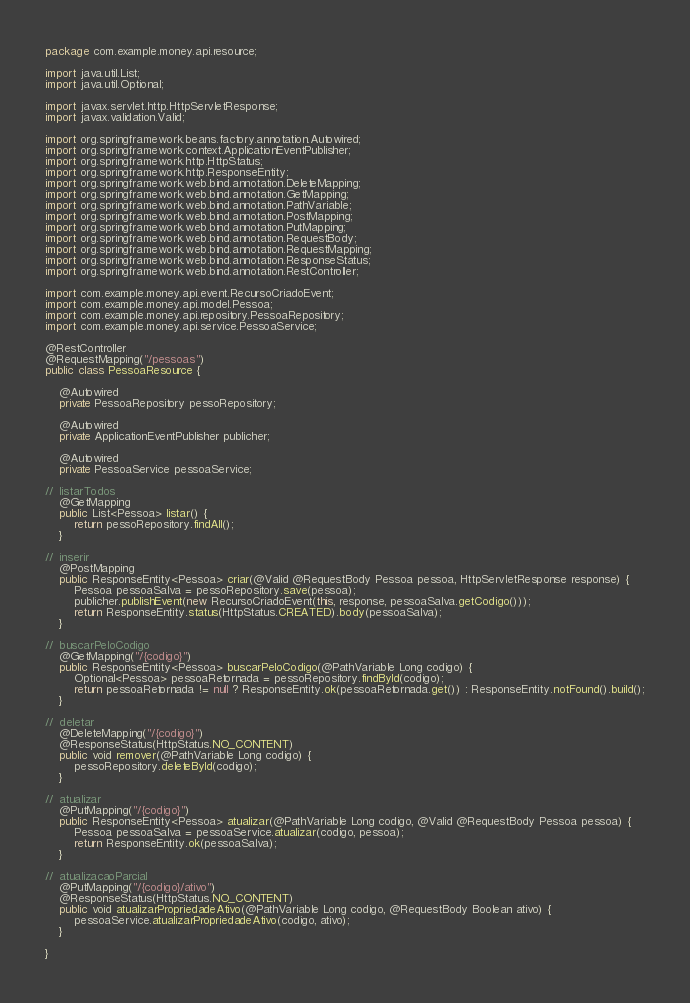<code> <loc_0><loc_0><loc_500><loc_500><_Java_>package com.example.money.api.resource;

import java.util.List;
import java.util.Optional;

import javax.servlet.http.HttpServletResponse;
import javax.validation.Valid;

import org.springframework.beans.factory.annotation.Autowired;
import org.springframework.context.ApplicationEventPublisher;
import org.springframework.http.HttpStatus;
import org.springframework.http.ResponseEntity;
import org.springframework.web.bind.annotation.DeleteMapping;
import org.springframework.web.bind.annotation.GetMapping;
import org.springframework.web.bind.annotation.PathVariable;
import org.springframework.web.bind.annotation.PostMapping;
import org.springframework.web.bind.annotation.PutMapping;
import org.springframework.web.bind.annotation.RequestBody;
import org.springframework.web.bind.annotation.RequestMapping;
import org.springframework.web.bind.annotation.ResponseStatus;
import org.springframework.web.bind.annotation.RestController;

import com.example.money.api.event.RecursoCriadoEvent;
import com.example.money.api.model.Pessoa;
import com.example.money.api.repository.PessoaRepository;
import com.example.money.api.service.PessoaService;

@RestController
@RequestMapping("/pessoas")
public class PessoaResource {

	@Autowired
	private PessoaRepository pessoRepository;

	@Autowired
	private ApplicationEventPublisher publicher;

	@Autowired
	private PessoaService pessoaService;

//	listarTodos
	@GetMapping
	public List<Pessoa> listar() {
		return pessoRepository.findAll();
	}

//	inserir
	@PostMapping
	public ResponseEntity<Pessoa> criar(@Valid @RequestBody Pessoa pessoa, HttpServletResponse response) {
		Pessoa pessoaSalva = pessoRepository.save(pessoa);
		publicher.publishEvent(new RecursoCriadoEvent(this, response, pessoaSalva.getCodigo()));
		return ResponseEntity.status(HttpStatus.CREATED).body(pessoaSalva);
	}

//	buscarPeloCodigo
	@GetMapping("/{codigo}")
	public ResponseEntity<Pessoa> buscarPeloCodigo(@PathVariable Long codigo) {
		Optional<Pessoa> pessoaRetornada = pessoRepository.findById(codigo);
		return pessoaRetornada != null ? ResponseEntity.ok(pessoaRetornada.get()) : ResponseEntity.notFound().build();
	}

//	deletar
	@DeleteMapping("/{codigo}")
	@ResponseStatus(HttpStatus.NO_CONTENT)
	public void remover(@PathVariable Long codigo) {
		pessoRepository.deleteById(codigo);
	}

//	atualizar
	@PutMapping("/{codigo}")
	public ResponseEntity<Pessoa> atualizar(@PathVariable Long codigo, @Valid @RequestBody Pessoa pessoa) {
		Pessoa pessoaSalva = pessoaService.atualizar(codigo, pessoa);
		return ResponseEntity.ok(pessoaSalva);
	}
	
//  atualizacaoParcial
	@PutMapping("/{codigo}/ativo")
	@ResponseStatus(HttpStatus.NO_CONTENT)
	public void atualizarPropriedadeAtivo(@PathVariable Long codigo, @RequestBody Boolean ativo) {
		pessoaService.atualizarPropriedadeAtivo(codigo, ativo);
	}
	
}
</code> 